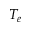Convert formula to latex. <formula><loc_0><loc_0><loc_500><loc_500>T _ { e }</formula> 